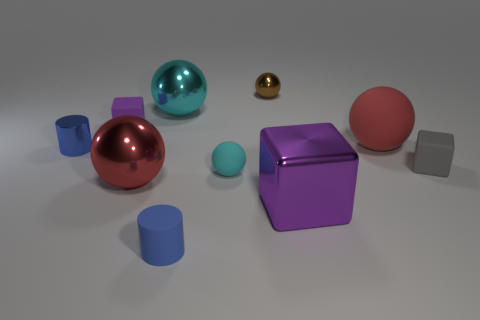Subtract all brown spheres. How many spheres are left? 4 Subtract all large red metal balls. How many balls are left? 4 Subtract all green spheres. Subtract all cyan cylinders. How many spheres are left? 5 Subtract all cylinders. How many objects are left? 8 Subtract 2 red balls. How many objects are left? 8 Subtract all gray rubber cubes. Subtract all large red cylinders. How many objects are left? 9 Add 4 small gray rubber cubes. How many small gray rubber cubes are left? 5 Add 1 tiny purple blocks. How many tiny purple blocks exist? 2 